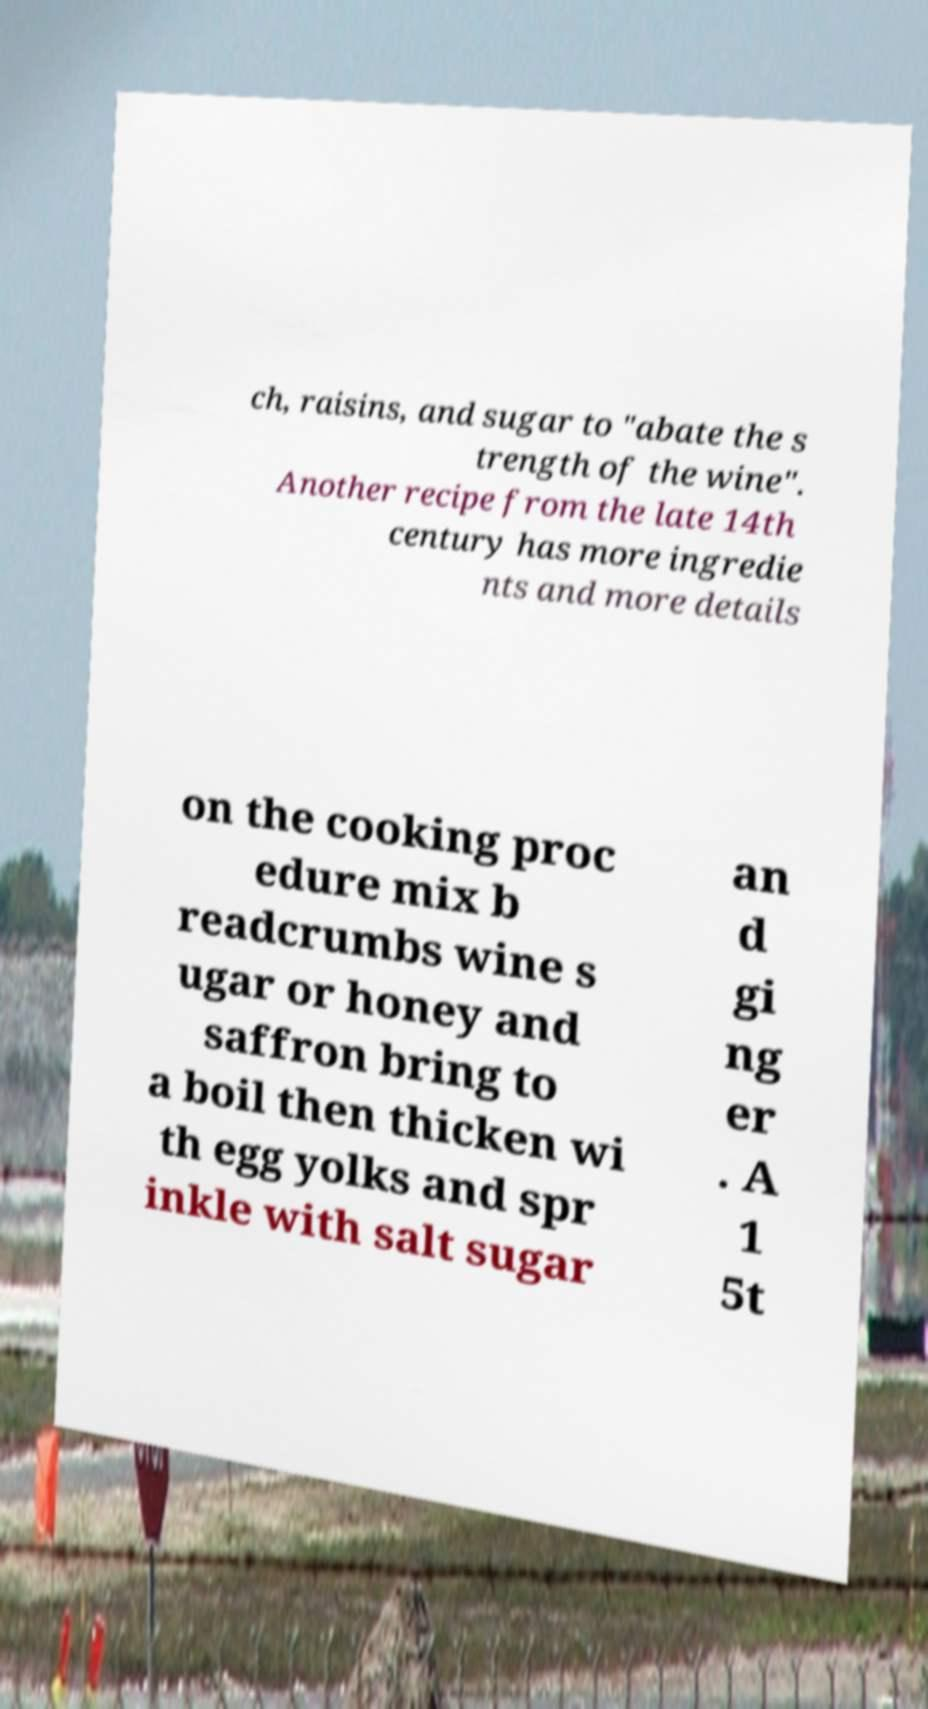Could you assist in decoding the text presented in this image and type it out clearly? ch, raisins, and sugar to "abate the s trength of the wine". Another recipe from the late 14th century has more ingredie nts and more details on the cooking proc edure mix b readcrumbs wine s ugar or honey and saffron bring to a boil then thicken wi th egg yolks and spr inkle with salt sugar an d gi ng er . A 1 5t 